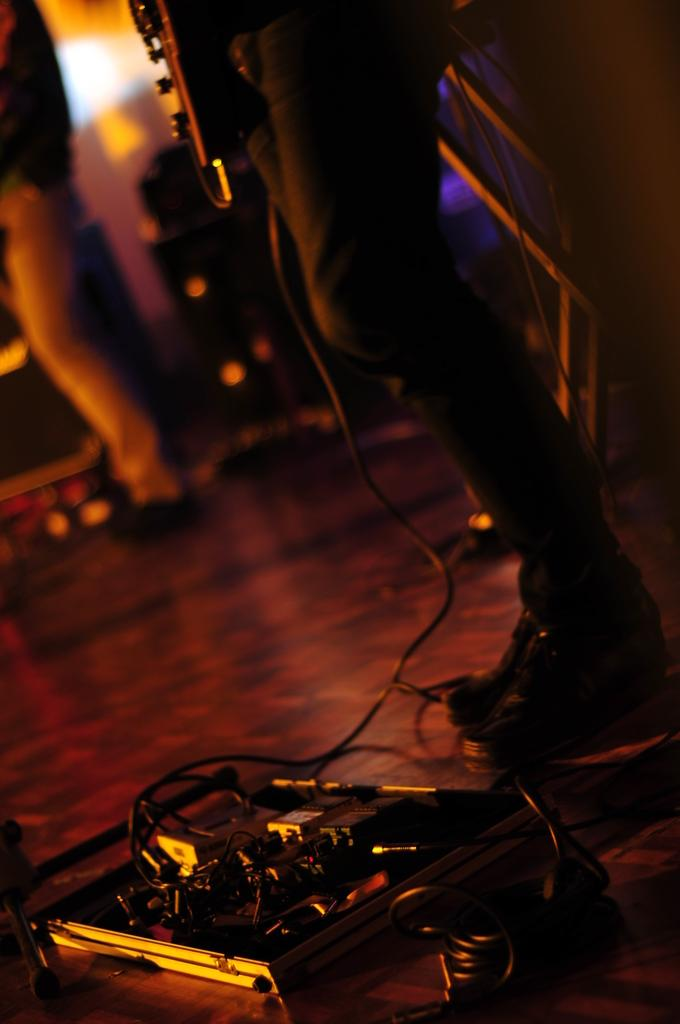How many people are present in the image? There are two persons standing in the image. What can be seen in addition to the people in the image? There appears to be a music system in the image. What is present on the floor in the image? There are cables on the floor in the image. Can you describe the background of the image? The background of the image is blurred. What type of ring is the frog wearing in the image? There is no frog or ring present in the image. 